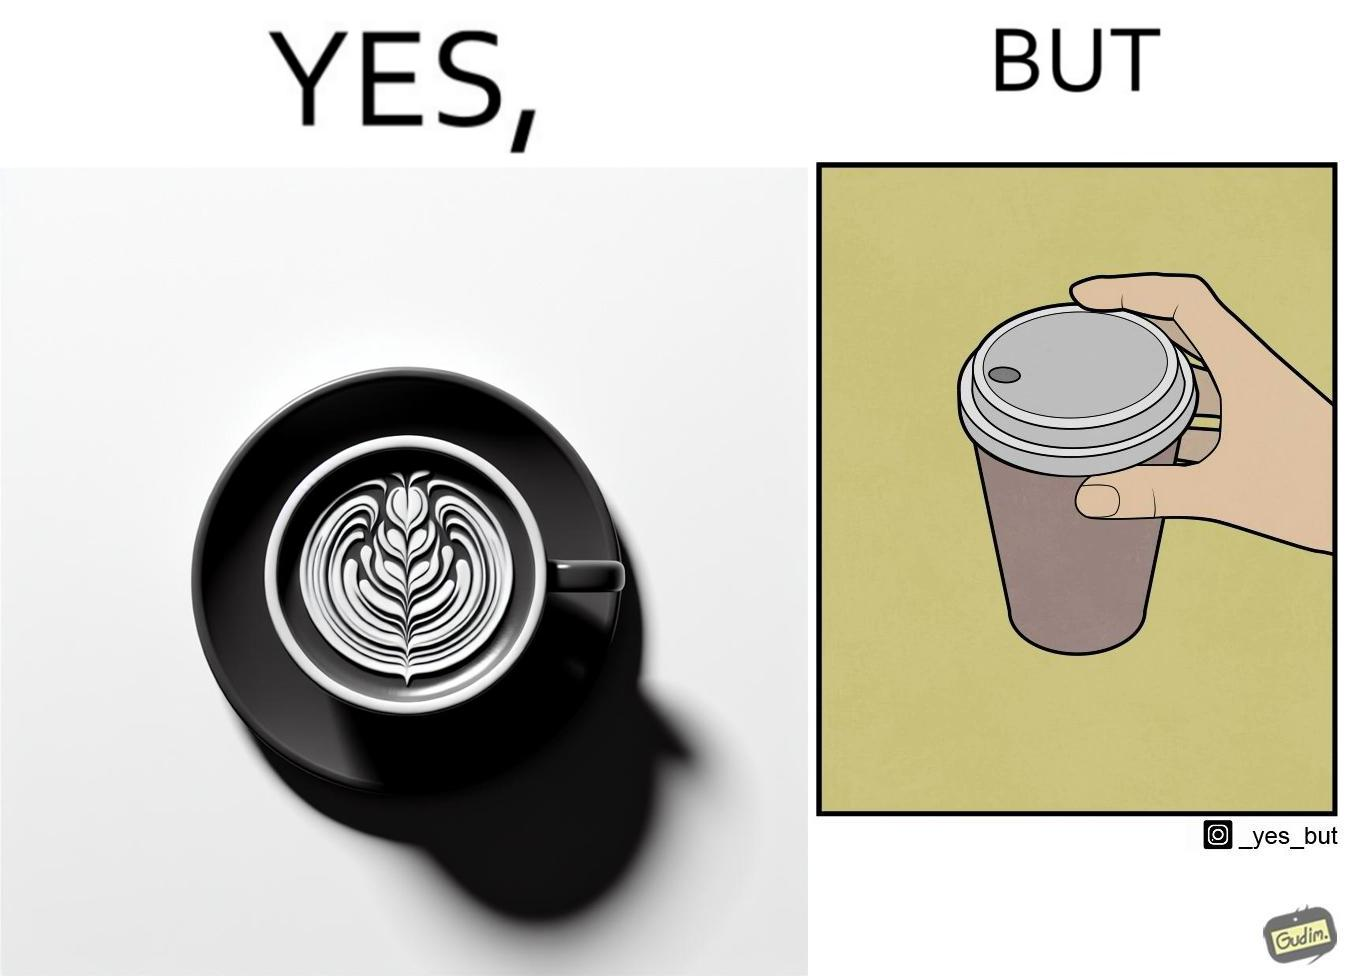Describe what you see in the left and right parts of this image. In the left part of the image: It is a cup of coffee with latte art In the right part of the image: It is a cup of coffee with its lid on top 